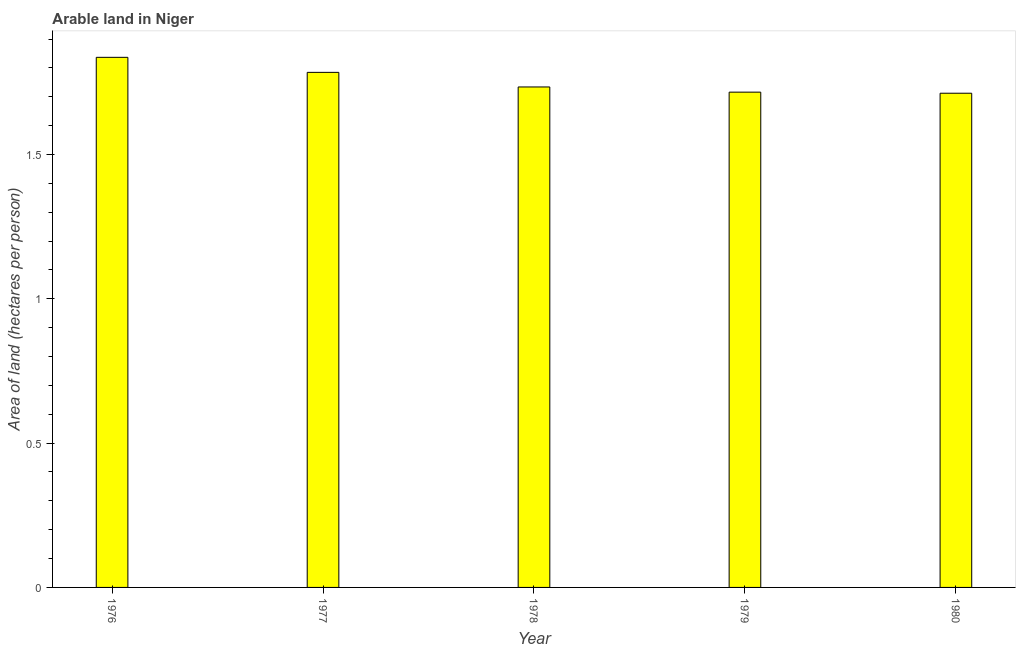Does the graph contain grids?
Provide a short and direct response. No. What is the title of the graph?
Keep it short and to the point. Arable land in Niger. What is the label or title of the X-axis?
Keep it short and to the point. Year. What is the label or title of the Y-axis?
Provide a succinct answer. Area of land (hectares per person). What is the area of arable land in 1978?
Your response must be concise. 1.73. Across all years, what is the maximum area of arable land?
Your response must be concise. 1.84. Across all years, what is the minimum area of arable land?
Make the answer very short. 1.71. In which year was the area of arable land maximum?
Your answer should be compact. 1976. In which year was the area of arable land minimum?
Give a very brief answer. 1980. What is the sum of the area of arable land?
Ensure brevity in your answer.  8.78. What is the difference between the area of arable land in 1979 and 1980?
Provide a short and direct response. 0. What is the average area of arable land per year?
Provide a succinct answer. 1.76. What is the median area of arable land?
Give a very brief answer. 1.73. Do a majority of the years between 1976 and 1980 (inclusive) have area of arable land greater than 0.5 hectares per person?
Offer a very short reply. Yes. What is the ratio of the area of arable land in 1977 to that in 1980?
Make the answer very short. 1.04. Is the area of arable land in 1977 less than that in 1980?
Your response must be concise. No. Is the difference between the area of arable land in 1977 and 1979 greater than the difference between any two years?
Offer a very short reply. No. What is the difference between the highest and the second highest area of arable land?
Offer a very short reply. 0.05. What is the difference between the highest and the lowest area of arable land?
Give a very brief answer. 0.12. How many bars are there?
Keep it short and to the point. 5. Are all the bars in the graph horizontal?
Offer a very short reply. No. How many years are there in the graph?
Give a very brief answer. 5. Are the values on the major ticks of Y-axis written in scientific E-notation?
Offer a very short reply. No. What is the Area of land (hectares per person) in 1976?
Provide a short and direct response. 1.84. What is the Area of land (hectares per person) in 1977?
Your answer should be very brief. 1.78. What is the Area of land (hectares per person) in 1978?
Provide a short and direct response. 1.73. What is the Area of land (hectares per person) of 1979?
Offer a very short reply. 1.72. What is the Area of land (hectares per person) in 1980?
Your answer should be very brief. 1.71. What is the difference between the Area of land (hectares per person) in 1976 and 1977?
Your answer should be very brief. 0.05. What is the difference between the Area of land (hectares per person) in 1976 and 1978?
Offer a terse response. 0.1. What is the difference between the Area of land (hectares per person) in 1976 and 1979?
Give a very brief answer. 0.12. What is the difference between the Area of land (hectares per person) in 1976 and 1980?
Provide a short and direct response. 0.12. What is the difference between the Area of land (hectares per person) in 1977 and 1978?
Give a very brief answer. 0.05. What is the difference between the Area of land (hectares per person) in 1977 and 1979?
Provide a short and direct response. 0.07. What is the difference between the Area of land (hectares per person) in 1977 and 1980?
Offer a terse response. 0.07. What is the difference between the Area of land (hectares per person) in 1978 and 1979?
Offer a terse response. 0.02. What is the difference between the Area of land (hectares per person) in 1978 and 1980?
Your answer should be very brief. 0.02. What is the difference between the Area of land (hectares per person) in 1979 and 1980?
Provide a short and direct response. 0. What is the ratio of the Area of land (hectares per person) in 1976 to that in 1977?
Your answer should be very brief. 1.03. What is the ratio of the Area of land (hectares per person) in 1976 to that in 1978?
Ensure brevity in your answer.  1.06. What is the ratio of the Area of land (hectares per person) in 1976 to that in 1979?
Offer a terse response. 1.07. What is the ratio of the Area of land (hectares per person) in 1976 to that in 1980?
Make the answer very short. 1.07. What is the ratio of the Area of land (hectares per person) in 1977 to that in 1980?
Offer a terse response. 1.04. What is the ratio of the Area of land (hectares per person) in 1978 to that in 1979?
Make the answer very short. 1.01. What is the ratio of the Area of land (hectares per person) in 1978 to that in 1980?
Your response must be concise. 1.01. What is the ratio of the Area of land (hectares per person) in 1979 to that in 1980?
Provide a succinct answer. 1. 